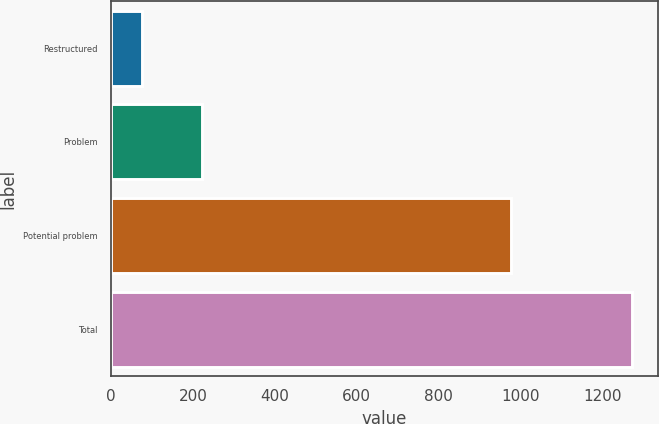<chart> <loc_0><loc_0><loc_500><loc_500><bar_chart><fcel>Restructured<fcel>Problem<fcel>Potential problem<fcel>Total<nl><fcel>75<fcel>221<fcel>977<fcel>1273<nl></chart> 